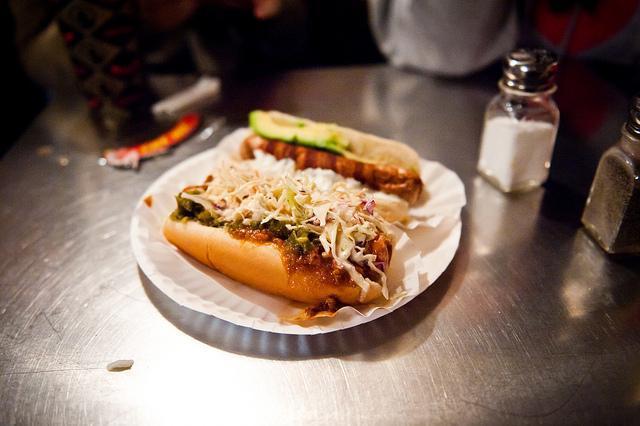How many hotdogs are on the plate?
Give a very brief answer. 2. How many hot dogs are on the plate?
Give a very brief answer. 2. How many hot dogs can you see?
Give a very brief answer. 2. How many bottles are in the picture?
Give a very brief answer. 2. How many fridge doors?
Give a very brief answer. 0. 